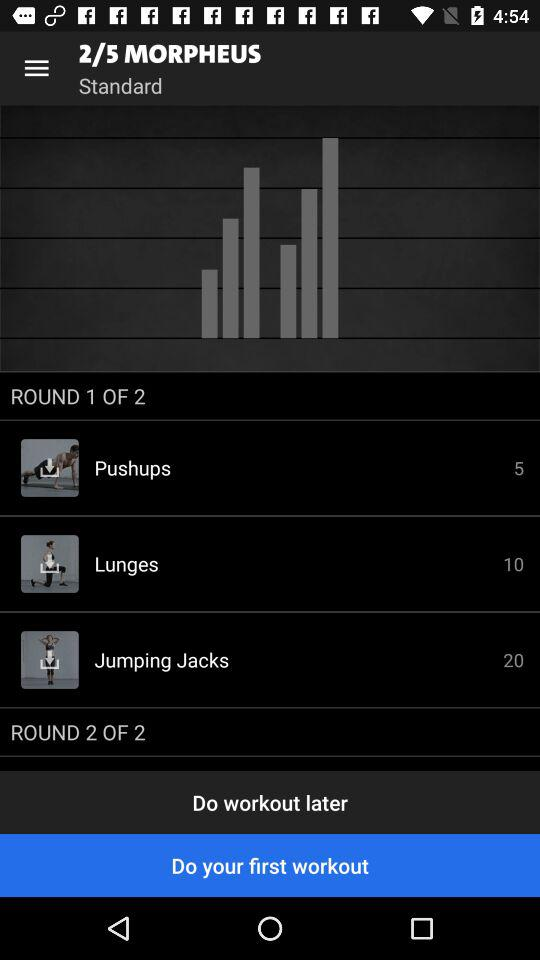How many reps of jumping jacks are there? There are 20 reps of jumping jacks. 